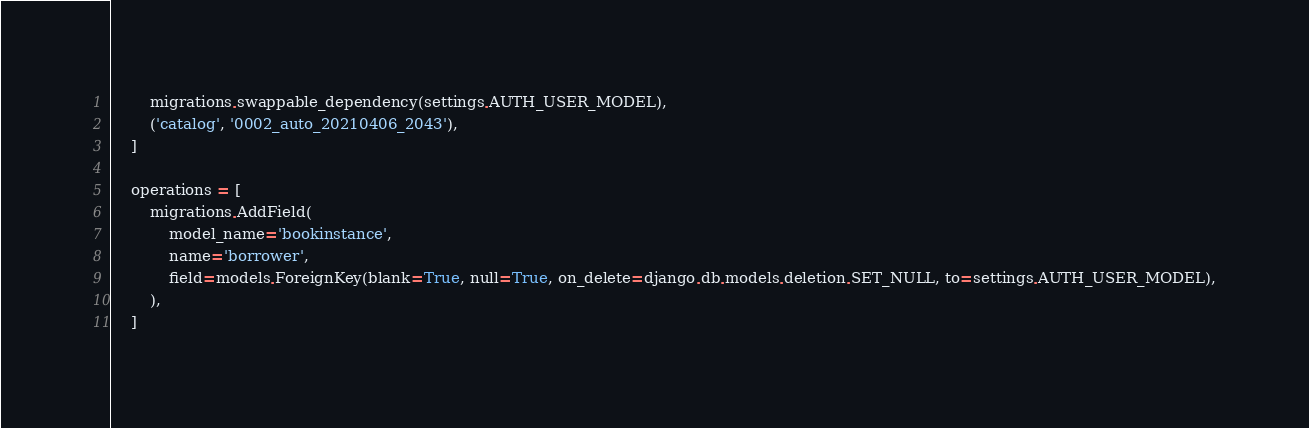<code> <loc_0><loc_0><loc_500><loc_500><_Python_>        migrations.swappable_dependency(settings.AUTH_USER_MODEL),
        ('catalog', '0002_auto_20210406_2043'),
    ]

    operations = [
        migrations.AddField(
            model_name='bookinstance',
            name='borrower',
            field=models.ForeignKey(blank=True, null=True, on_delete=django.db.models.deletion.SET_NULL, to=settings.AUTH_USER_MODEL),
        ),
    ]
</code> 